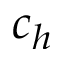<formula> <loc_0><loc_0><loc_500><loc_500>c _ { h }</formula> 